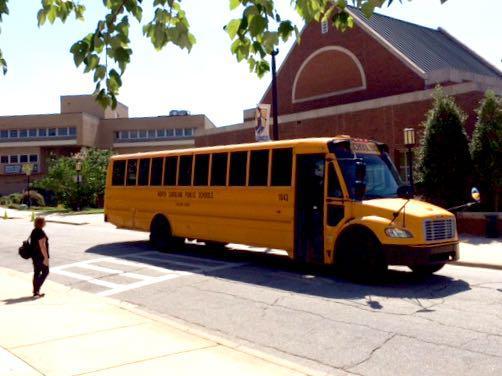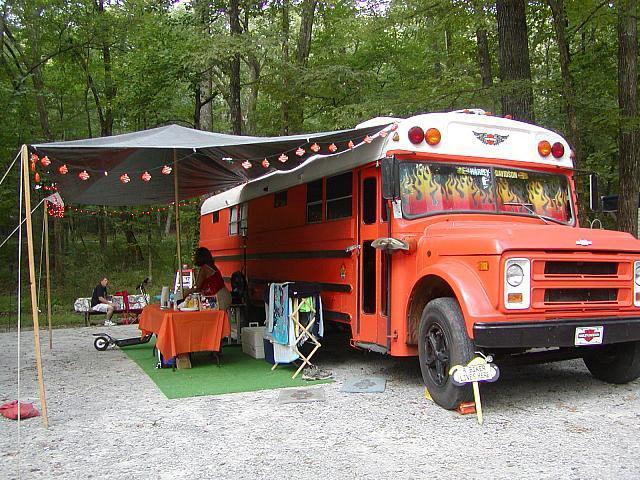The first image is the image on the left, the second image is the image on the right. Given the left and right images, does the statement "One of the buses is a traditional yellow color while the other is more of a reddish hue." hold true? Answer yes or no. Yes. The first image is the image on the left, the second image is the image on the right. Analyze the images presented: Is the assertion "The right image contains a red-orange bus angled facing rightward." valid? Answer yes or no. Yes. 